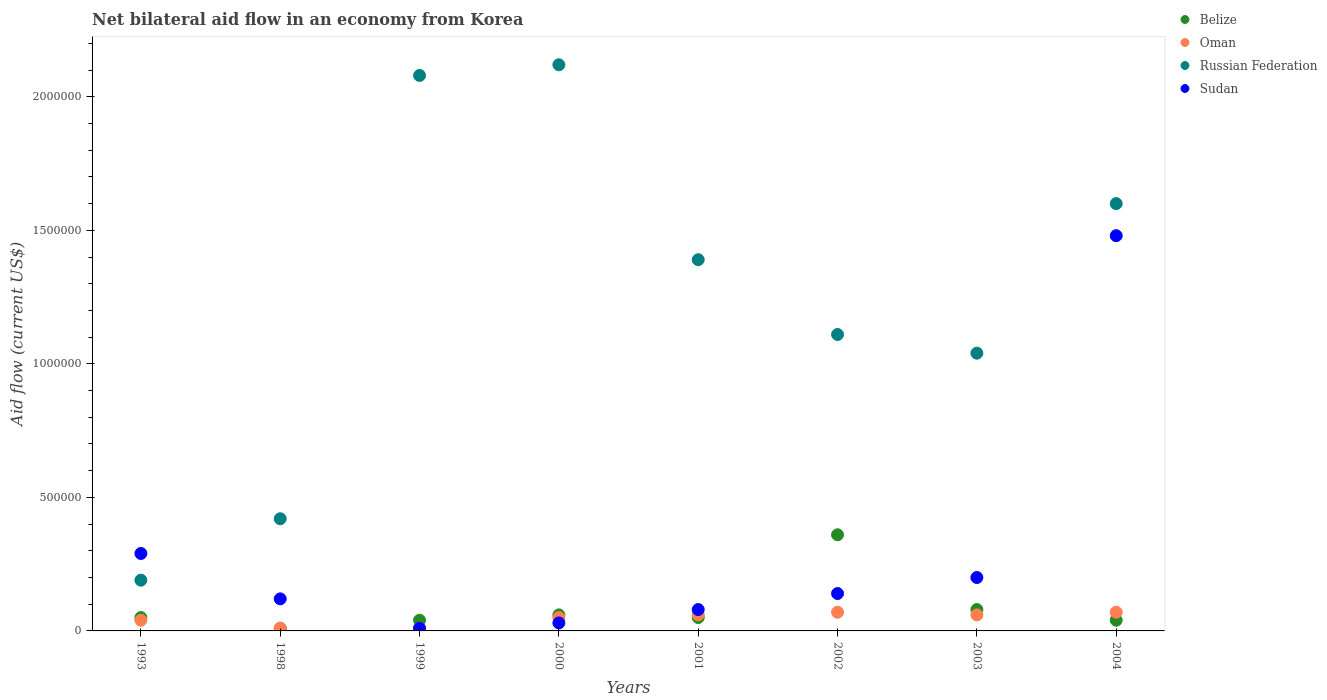How many different coloured dotlines are there?
Make the answer very short. 4. Is the number of dotlines equal to the number of legend labels?
Provide a succinct answer. Yes. Across all years, what is the maximum net bilateral aid flow in Oman?
Your response must be concise. 7.00e+04. Across all years, what is the minimum net bilateral aid flow in Russian Federation?
Your response must be concise. 1.90e+05. In which year was the net bilateral aid flow in Belize maximum?
Provide a succinct answer. 2002. What is the total net bilateral aid flow in Oman in the graph?
Your response must be concise. 3.70e+05. What is the difference between the net bilateral aid flow in Sudan in 2000 and that in 2004?
Give a very brief answer. -1.45e+06. What is the difference between the net bilateral aid flow in Oman in 2003 and the net bilateral aid flow in Russian Federation in 1999?
Give a very brief answer. -2.02e+06. What is the average net bilateral aid flow in Belize per year?
Provide a short and direct response. 8.62e+04. In the year 2003, what is the difference between the net bilateral aid flow in Russian Federation and net bilateral aid flow in Belize?
Provide a short and direct response. 9.60e+05. In how many years, is the net bilateral aid flow in Oman greater than 1800000 US$?
Offer a very short reply. 0. What is the ratio of the net bilateral aid flow in Sudan in 2001 to that in 2003?
Offer a very short reply. 0.4. Is the net bilateral aid flow in Russian Federation in 1993 less than that in 2003?
Offer a very short reply. Yes. What is the difference between the highest and the lowest net bilateral aid flow in Oman?
Offer a terse response. 6.00e+04. Is it the case that in every year, the sum of the net bilateral aid flow in Russian Federation and net bilateral aid flow in Sudan  is greater than the net bilateral aid flow in Belize?
Your response must be concise. Yes. Does the net bilateral aid flow in Belize monotonically increase over the years?
Provide a short and direct response. No. How many years are there in the graph?
Offer a terse response. 8. What is the difference between two consecutive major ticks on the Y-axis?
Make the answer very short. 5.00e+05. Does the graph contain any zero values?
Offer a terse response. No. Where does the legend appear in the graph?
Ensure brevity in your answer.  Top right. What is the title of the graph?
Your answer should be very brief. Net bilateral aid flow in an economy from Korea. Does "Qatar" appear as one of the legend labels in the graph?
Your answer should be very brief. No. What is the Aid flow (current US$) in Oman in 1993?
Give a very brief answer. 4.00e+04. What is the Aid flow (current US$) in Russian Federation in 1993?
Provide a short and direct response. 1.90e+05. What is the Aid flow (current US$) of Sudan in 1993?
Offer a terse response. 2.90e+05. What is the Aid flow (current US$) of Russian Federation in 1999?
Offer a terse response. 2.08e+06. What is the Aid flow (current US$) in Belize in 2000?
Your answer should be very brief. 6.00e+04. What is the Aid flow (current US$) in Russian Federation in 2000?
Offer a terse response. 2.12e+06. What is the Aid flow (current US$) in Sudan in 2000?
Your answer should be very brief. 3.00e+04. What is the Aid flow (current US$) in Russian Federation in 2001?
Your response must be concise. 1.39e+06. What is the Aid flow (current US$) in Belize in 2002?
Offer a terse response. 3.60e+05. What is the Aid flow (current US$) of Oman in 2002?
Make the answer very short. 7.00e+04. What is the Aid flow (current US$) of Russian Federation in 2002?
Provide a short and direct response. 1.11e+06. What is the Aid flow (current US$) in Belize in 2003?
Provide a succinct answer. 8.00e+04. What is the Aid flow (current US$) in Russian Federation in 2003?
Keep it short and to the point. 1.04e+06. What is the Aid flow (current US$) in Belize in 2004?
Provide a short and direct response. 4.00e+04. What is the Aid flow (current US$) of Oman in 2004?
Make the answer very short. 7.00e+04. What is the Aid flow (current US$) of Russian Federation in 2004?
Provide a succinct answer. 1.60e+06. What is the Aid flow (current US$) of Sudan in 2004?
Provide a succinct answer. 1.48e+06. Across all years, what is the maximum Aid flow (current US$) of Belize?
Your answer should be compact. 3.60e+05. Across all years, what is the maximum Aid flow (current US$) of Oman?
Keep it short and to the point. 7.00e+04. Across all years, what is the maximum Aid flow (current US$) in Russian Federation?
Keep it short and to the point. 2.12e+06. Across all years, what is the maximum Aid flow (current US$) in Sudan?
Make the answer very short. 1.48e+06. Across all years, what is the minimum Aid flow (current US$) in Belize?
Make the answer very short. 10000. What is the total Aid flow (current US$) of Belize in the graph?
Offer a terse response. 6.90e+05. What is the total Aid flow (current US$) of Oman in the graph?
Your answer should be compact. 3.70e+05. What is the total Aid flow (current US$) of Russian Federation in the graph?
Keep it short and to the point. 9.95e+06. What is the total Aid flow (current US$) in Sudan in the graph?
Your response must be concise. 2.35e+06. What is the difference between the Aid flow (current US$) in Belize in 1993 and that in 1998?
Offer a very short reply. 4.00e+04. What is the difference between the Aid flow (current US$) in Oman in 1993 and that in 1998?
Your answer should be very brief. 3.00e+04. What is the difference between the Aid flow (current US$) in Oman in 1993 and that in 1999?
Make the answer very short. 3.00e+04. What is the difference between the Aid flow (current US$) in Russian Federation in 1993 and that in 1999?
Offer a very short reply. -1.89e+06. What is the difference between the Aid flow (current US$) in Sudan in 1993 and that in 1999?
Provide a succinct answer. 2.80e+05. What is the difference between the Aid flow (current US$) of Belize in 1993 and that in 2000?
Provide a succinct answer. -10000. What is the difference between the Aid flow (current US$) of Oman in 1993 and that in 2000?
Offer a very short reply. -10000. What is the difference between the Aid flow (current US$) of Russian Federation in 1993 and that in 2000?
Your answer should be very brief. -1.93e+06. What is the difference between the Aid flow (current US$) of Russian Federation in 1993 and that in 2001?
Give a very brief answer. -1.20e+06. What is the difference between the Aid flow (current US$) in Belize in 1993 and that in 2002?
Offer a very short reply. -3.10e+05. What is the difference between the Aid flow (current US$) in Russian Federation in 1993 and that in 2002?
Make the answer very short. -9.20e+05. What is the difference between the Aid flow (current US$) of Sudan in 1993 and that in 2002?
Provide a succinct answer. 1.50e+05. What is the difference between the Aid flow (current US$) of Belize in 1993 and that in 2003?
Offer a very short reply. -3.00e+04. What is the difference between the Aid flow (current US$) of Oman in 1993 and that in 2003?
Provide a succinct answer. -2.00e+04. What is the difference between the Aid flow (current US$) of Russian Federation in 1993 and that in 2003?
Provide a short and direct response. -8.50e+05. What is the difference between the Aid flow (current US$) of Russian Federation in 1993 and that in 2004?
Provide a succinct answer. -1.41e+06. What is the difference between the Aid flow (current US$) of Sudan in 1993 and that in 2004?
Ensure brevity in your answer.  -1.19e+06. What is the difference between the Aid flow (current US$) in Russian Federation in 1998 and that in 1999?
Keep it short and to the point. -1.66e+06. What is the difference between the Aid flow (current US$) in Belize in 1998 and that in 2000?
Give a very brief answer. -5.00e+04. What is the difference between the Aid flow (current US$) of Russian Federation in 1998 and that in 2000?
Your answer should be very brief. -1.70e+06. What is the difference between the Aid flow (current US$) in Belize in 1998 and that in 2001?
Offer a terse response. -4.00e+04. What is the difference between the Aid flow (current US$) of Russian Federation in 1998 and that in 2001?
Ensure brevity in your answer.  -9.70e+05. What is the difference between the Aid flow (current US$) of Belize in 1998 and that in 2002?
Your answer should be very brief. -3.50e+05. What is the difference between the Aid flow (current US$) of Russian Federation in 1998 and that in 2002?
Offer a terse response. -6.90e+05. What is the difference between the Aid flow (current US$) in Sudan in 1998 and that in 2002?
Ensure brevity in your answer.  -2.00e+04. What is the difference between the Aid flow (current US$) of Belize in 1998 and that in 2003?
Ensure brevity in your answer.  -7.00e+04. What is the difference between the Aid flow (current US$) in Russian Federation in 1998 and that in 2003?
Your answer should be very brief. -6.20e+05. What is the difference between the Aid flow (current US$) of Belize in 1998 and that in 2004?
Keep it short and to the point. -3.00e+04. What is the difference between the Aid flow (current US$) in Russian Federation in 1998 and that in 2004?
Ensure brevity in your answer.  -1.18e+06. What is the difference between the Aid flow (current US$) of Sudan in 1998 and that in 2004?
Your answer should be compact. -1.36e+06. What is the difference between the Aid flow (current US$) of Belize in 1999 and that in 2000?
Make the answer very short. -2.00e+04. What is the difference between the Aid flow (current US$) of Russian Federation in 1999 and that in 2000?
Make the answer very short. -4.00e+04. What is the difference between the Aid flow (current US$) of Oman in 1999 and that in 2001?
Ensure brevity in your answer.  -5.00e+04. What is the difference between the Aid flow (current US$) in Russian Federation in 1999 and that in 2001?
Offer a very short reply. 6.90e+05. What is the difference between the Aid flow (current US$) of Sudan in 1999 and that in 2001?
Make the answer very short. -7.00e+04. What is the difference between the Aid flow (current US$) of Belize in 1999 and that in 2002?
Give a very brief answer. -3.20e+05. What is the difference between the Aid flow (current US$) of Oman in 1999 and that in 2002?
Offer a terse response. -6.00e+04. What is the difference between the Aid flow (current US$) in Russian Federation in 1999 and that in 2002?
Offer a very short reply. 9.70e+05. What is the difference between the Aid flow (current US$) in Sudan in 1999 and that in 2002?
Offer a terse response. -1.30e+05. What is the difference between the Aid flow (current US$) in Belize in 1999 and that in 2003?
Your answer should be compact. -4.00e+04. What is the difference between the Aid flow (current US$) in Oman in 1999 and that in 2003?
Offer a terse response. -5.00e+04. What is the difference between the Aid flow (current US$) of Russian Federation in 1999 and that in 2003?
Keep it short and to the point. 1.04e+06. What is the difference between the Aid flow (current US$) of Russian Federation in 1999 and that in 2004?
Offer a very short reply. 4.80e+05. What is the difference between the Aid flow (current US$) in Sudan in 1999 and that in 2004?
Offer a terse response. -1.47e+06. What is the difference between the Aid flow (current US$) in Oman in 2000 and that in 2001?
Your answer should be very brief. -10000. What is the difference between the Aid flow (current US$) of Russian Federation in 2000 and that in 2001?
Your answer should be very brief. 7.30e+05. What is the difference between the Aid flow (current US$) in Oman in 2000 and that in 2002?
Ensure brevity in your answer.  -2.00e+04. What is the difference between the Aid flow (current US$) of Russian Federation in 2000 and that in 2002?
Make the answer very short. 1.01e+06. What is the difference between the Aid flow (current US$) in Oman in 2000 and that in 2003?
Your answer should be very brief. -10000. What is the difference between the Aid flow (current US$) in Russian Federation in 2000 and that in 2003?
Your answer should be very brief. 1.08e+06. What is the difference between the Aid flow (current US$) of Sudan in 2000 and that in 2003?
Your answer should be compact. -1.70e+05. What is the difference between the Aid flow (current US$) of Russian Federation in 2000 and that in 2004?
Your response must be concise. 5.20e+05. What is the difference between the Aid flow (current US$) of Sudan in 2000 and that in 2004?
Offer a terse response. -1.45e+06. What is the difference between the Aid flow (current US$) in Belize in 2001 and that in 2002?
Keep it short and to the point. -3.10e+05. What is the difference between the Aid flow (current US$) in Oman in 2001 and that in 2002?
Your answer should be compact. -10000. What is the difference between the Aid flow (current US$) in Belize in 2001 and that in 2003?
Offer a terse response. -3.00e+04. What is the difference between the Aid flow (current US$) in Oman in 2001 and that in 2003?
Ensure brevity in your answer.  0. What is the difference between the Aid flow (current US$) in Russian Federation in 2001 and that in 2003?
Provide a short and direct response. 3.50e+05. What is the difference between the Aid flow (current US$) in Sudan in 2001 and that in 2003?
Give a very brief answer. -1.20e+05. What is the difference between the Aid flow (current US$) in Belize in 2001 and that in 2004?
Your answer should be very brief. 10000. What is the difference between the Aid flow (current US$) of Oman in 2001 and that in 2004?
Offer a terse response. -10000. What is the difference between the Aid flow (current US$) in Russian Federation in 2001 and that in 2004?
Offer a very short reply. -2.10e+05. What is the difference between the Aid flow (current US$) in Sudan in 2001 and that in 2004?
Make the answer very short. -1.40e+06. What is the difference between the Aid flow (current US$) of Oman in 2002 and that in 2003?
Keep it short and to the point. 10000. What is the difference between the Aid flow (current US$) in Russian Federation in 2002 and that in 2003?
Provide a short and direct response. 7.00e+04. What is the difference between the Aid flow (current US$) of Sudan in 2002 and that in 2003?
Ensure brevity in your answer.  -6.00e+04. What is the difference between the Aid flow (current US$) in Oman in 2002 and that in 2004?
Ensure brevity in your answer.  0. What is the difference between the Aid flow (current US$) of Russian Federation in 2002 and that in 2004?
Offer a very short reply. -4.90e+05. What is the difference between the Aid flow (current US$) in Sudan in 2002 and that in 2004?
Ensure brevity in your answer.  -1.34e+06. What is the difference between the Aid flow (current US$) in Oman in 2003 and that in 2004?
Keep it short and to the point. -10000. What is the difference between the Aid flow (current US$) in Russian Federation in 2003 and that in 2004?
Offer a terse response. -5.60e+05. What is the difference between the Aid flow (current US$) of Sudan in 2003 and that in 2004?
Your response must be concise. -1.28e+06. What is the difference between the Aid flow (current US$) in Belize in 1993 and the Aid flow (current US$) in Russian Federation in 1998?
Provide a succinct answer. -3.70e+05. What is the difference between the Aid flow (current US$) in Oman in 1993 and the Aid flow (current US$) in Russian Federation in 1998?
Provide a short and direct response. -3.80e+05. What is the difference between the Aid flow (current US$) in Oman in 1993 and the Aid flow (current US$) in Sudan in 1998?
Your answer should be compact. -8.00e+04. What is the difference between the Aid flow (current US$) of Russian Federation in 1993 and the Aid flow (current US$) of Sudan in 1998?
Offer a very short reply. 7.00e+04. What is the difference between the Aid flow (current US$) of Belize in 1993 and the Aid flow (current US$) of Russian Federation in 1999?
Make the answer very short. -2.03e+06. What is the difference between the Aid flow (current US$) of Belize in 1993 and the Aid flow (current US$) of Sudan in 1999?
Give a very brief answer. 4.00e+04. What is the difference between the Aid flow (current US$) of Oman in 1993 and the Aid flow (current US$) of Russian Federation in 1999?
Make the answer very short. -2.04e+06. What is the difference between the Aid flow (current US$) of Oman in 1993 and the Aid flow (current US$) of Sudan in 1999?
Provide a short and direct response. 3.00e+04. What is the difference between the Aid flow (current US$) of Russian Federation in 1993 and the Aid flow (current US$) of Sudan in 1999?
Offer a terse response. 1.80e+05. What is the difference between the Aid flow (current US$) of Belize in 1993 and the Aid flow (current US$) of Oman in 2000?
Your response must be concise. 0. What is the difference between the Aid flow (current US$) in Belize in 1993 and the Aid flow (current US$) in Russian Federation in 2000?
Provide a short and direct response. -2.07e+06. What is the difference between the Aid flow (current US$) of Belize in 1993 and the Aid flow (current US$) of Sudan in 2000?
Ensure brevity in your answer.  2.00e+04. What is the difference between the Aid flow (current US$) in Oman in 1993 and the Aid flow (current US$) in Russian Federation in 2000?
Keep it short and to the point. -2.08e+06. What is the difference between the Aid flow (current US$) of Oman in 1993 and the Aid flow (current US$) of Sudan in 2000?
Your answer should be compact. 10000. What is the difference between the Aid flow (current US$) of Russian Federation in 1993 and the Aid flow (current US$) of Sudan in 2000?
Offer a very short reply. 1.60e+05. What is the difference between the Aid flow (current US$) in Belize in 1993 and the Aid flow (current US$) in Oman in 2001?
Give a very brief answer. -10000. What is the difference between the Aid flow (current US$) in Belize in 1993 and the Aid flow (current US$) in Russian Federation in 2001?
Provide a succinct answer. -1.34e+06. What is the difference between the Aid flow (current US$) of Oman in 1993 and the Aid flow (current US$) of Russian Federation in 2001?
Ensure brevity in your answer.  -1.35e+06. What is the difference between the Aid flow (current US$) in Oman in 1993 and the Aid flow (current US$) in Sudan in 2001?
Your answer should be compact. -4.00e+04. What is the difference between the Aid flow (current US$) of Belize in 1993 and the Aid flow (current US$) of Russian Federation in 2002?
Keep it short and to the point. -1.06e+06. What is the difference between the Aid flow (current US$) in Oman in 1993 and the Aid flow (current US$) in Russian Federation in 2002?
Your response must be concise. -1.07e+06. What is the difference between the Aid flow (current US$) of Belize in 1993 and the Aid flow (current US$) of Russian Federation in 2003?
Ensure brevity in your answer.  -9.90e+05. What is the difference between the Aid flow (current US$) of Oman in 1993 and the Aid flow (current US$) of Russian Federation in 2003?
Offer a terse response. -1.00e+06. What is the difference between the Aid flow (current US$) of Oman in 1993 and the Aid flow (current US$) of Sudan in 2003?
Offer a terse response. -1.60e+05. What is the difference between the Aid flow (current US$) in Russian Federation in 1993 and the Aid flow (current US$) in Sudan in 2003?
Ensure brevity in your answer.  -10000. What is the difference between the Aid flow (current US$) in Belize in 1993 and the Aid flow (current US$) in Russian Federation in 2004?
Your answer should be very brief. -1.55e+06. What is the difference between the Aid flow (current US$) of Belize in 1993 and the Aid flow (current US$) of Sudan in 2004?
Your answer should be very brief. -1.43e+06. What is the difference between the Aid flow (current US$) in Oman in 1993 and the Aid flow (current US$) in Russian Federation in 2004?
Provide a short and direct response. -1.56e+06. What is the difference between the Aid flow (current US$) of Oman in 1993 and the Aid flow (current US$) of Sudan in 2004?
Ensure brevity in your answer.  -1.44e+06. What is the difference between the Aid flow (current US$) of Russian Federation in 1993 and the Aid flow (current US$) of Sudan in 2004?
Offer a very short reply. -1.29e+06. What is the difference between the Aid flow (current US$) in Belize in 1998 and the Aid flow (current US$) in Russian Federation in 1999?
Make the answer very short. -2.07e+06. What is the difference between the Aid flow (current US$) in Oman in 1998 and the Aid flow (current US$) in Russian Federation in 1999?
Provide a succinct answer. -2.07e+06. What is the difference between the Aid flow (current US$) of Russian Federation in 1998 and the Aid flow (current US$) of Sudan in 1999?
Provide a short and direct response. 4.10e+05. What is the difference between the Aid flow (current US$) of Belize in 1998 and the Aid flow (current US$) of Oman in 2000?
Offer a terse response. -4.00e+04. What is the difference between the Aid flow (current US$) of Belize in 1998 and the Aid flow (current US$) of Russian Federation in 2000?
Keep it short and to the point. -2.11e+06. What is the difference between the Aid flow (current US$) in Belize in 1998 and the Aid flow (current US$) in Sudan in 2000?
Offer a very short reply. -2.00e+04. What is the difference between the Aid flow (current US$) in Oman in 1998 and the Aid flow (current US$) in Russian Federation in 2000?
Provide a short and direct response. -2.11e+06. What is the difference between the Aid flow (current US$) in Russian Federation in 1998 and the Aid flow (current US$) in Sudan in 2000?
Keep it short and to the point. 3.90e+05. What is the difference between the Aid flow (current US$) in Belize in 1998 and the Aid flow (current US$) in Oman in 2001?
Give a very brief answer. -5.00e+04. What is the difference between the Aid flow (current US$) in Belize in 1998 and the Aid flow (current US$) in Russian Federation in 2001?
Offer a terse response. -1.38e+06. What is the difference between the Aid flow (current US$) of Belize in 1998 and the Aid flow (current US$) of Sudan in 2001?
Provide a short and direct response. -7.00e+04. What is the difference between the Aid flow (current US$) of Oman in 1998 and the Aid flow (current US$) of Russian Federation in 2001?
Your answer should be very brief. -1.38e+06. What is the difference between the Aid flow (current US$) of Oman in 1998 and the Aid flow (current US$) of Sudan in 2001?
Make the answer very short. -7.00e+04. What is the difference between the Aid flow (current US$) in Belize in 1998 and the Aid flow (current US$) in Russian Federation in 2002?
Offer a terse response. -1.10e+06. What is the difference between the Aid flow (current US$) of Belize in 1998 and the Aid flow (current US$) of Sudan in 2002?
Your response must be concise. -1.30e+05. What is the difference between the Aid flow (current US$) of Oman in 1998 and the Aid flow (current US$) of Russian Federation in 2002?
Make the answer very short. -1.10e+06. What is the difference between the Aid flow (current US$) in Belize in 1998 and the Aid flow (current US$) in Russian Federation in 2003?
Provide a succinct answer. -1.03e+06. What is the difference between the Aid flow (current US$) of Belize in 1998 and the Aid flow (current US$) of Sudan in 2003?
Keep it short and to the point. -1.90e+05. What is the difference between the Aid flow (current US$) of Oman in 1998 and the Aid flow (current US$) of Russian Federation in 2003?
Keep it short and to the point. -1.03e+06. What is the difference between the Aid flow (current US$) in Oman in 1998 and the Aid flow (current US$) in Sudan in 2003?
Give a very brief answer. -1.90e+05. What is the difference between the Aid flow (current US$) in Russian Federation in 1998 and the Aid flow (current US$) in Sudan in 2003?
Ensure brevity in your answer.  2.20e+05. What is the difference between the Aid flow (current US$) in Belize in 1998 and the Aid flow (current US$) in Oman in 2004?
Offer a terse response. -6.00e+04. What is the difference between the Aid flow (current US$) in Belize in 1998 and the Aid flow (current US$) in Russian Federation in 2004?
Your answer should be very brief. -1.59e+06. What is the difference between the Aid flow (current US$) of Belize in 1998 and the Aid flow (current US$) of Sudan in 2004?
Provide a succinct answer. -1.47e+06. What is the difference between the Aid flow (current US$) in Oman in 1998 and the Aid flow (current US$) in Russian Federation in 2004?
Make the answer very short. -1.59e+06. What is the difference between the Aid flow (current US$) in Oman in 1998 and the Aid flow (current US$) in Sudan in 2004?
Provide a short and direct response. -1.47e+06. What is the difference between the Aid flow (current US$) of Russian Federation in 1998 and the Aid flow (current US$) of Sudan in 2004?
Provide a short and direct response. -1.06e+06. What is the difference between the Aid flow (current US$) of Belize in 1999 and the Aid flow (current US$) of Oman in 2000?
Provide a succinct answer. -10000. What is the difference between the Aid flow (current US$) in Belize in 1999 and the Aid flow (current US$) in Russian Federation in 2000?
Offer a very short reply. -2.08e+06. What is the difference between the Aid flow (current US$) of Belize in 1999 and the Aid flow (current US$) of Sudan in 2000?
Provide a succinct answer. 10000. What is the difference between the Aid flow (current US$) of Oman in 1999 and the Aid flow (current US$) of Russian Federation in 2000?
Your response must be concise. -2.11e+06. What is the difference between the Aid flow (current US$) of Russian Federation in 1999 and the Aid flow (current US$) of Sudan in 2000?
Ensure brevity in your answer.  2.05e+06. What is the difference between the Aid flow (current US$) of Belize in 1999 and the Aid flow (current US$) of Oman in 2001?
Ensure brevity in your answer.  -2.00e+04. What is the difference between the Aid flow (current US$) of Belize in 1999 and the Aid flow (current US$) of Russian Federation in 2001?
Offer a terse response. -1.35e+06. What is the difference between the Aid flow (current US$) of Oman in 1999 and the Aid flow (current US$) of Russian Federation in 2001?
Offer a terse response. -1.38e+06. What is the difference between the Aid flow (current US$) of Russian Federation in 1999 and the Aid flow (current US$) of Sudan in 2001?
Provide a short and direct response. 2.00e+06. What is the difference between the Aid flow (current US$) in Belize in 1999 and the Aid flow (current US$) in Oman in 2002?
Offer a terse response. -3.00e+04. What is the difference between the Aid flow (current US$) in Belize in 1999 and the Aid flow (current US$) in Russian Federation in 2002?
Offer a very short reply. -1.07e+06. What is the difference between the Aid flow (current US$) in Oman in 1999 and the Aid flow (current US$) in Russian Federation in 2002?
Offer a very short reply. -1.10e+06. What is the difference between the Aid flow (current US$) in Russian Federation in 1999 and the Aid flow (current US$) in Sudan in 2002?
Offer a terse response. 1.94e+06. What is the difference between the Aid flow (current US$) of Belize in 1999 and the Aid flow (current US$) of Oman in 2003?
Provide a short and direct response. -2.00e+04. What is the difference between the Aid flow (current US$) of Belize in 1999 and the Aid flow (current US$) of Russian Federation in 2003?
Your answer should be compact. -1.00e+06. What is the difference between the Aid flow (current US$) in Belize in 1999 and the Aid flow (current US$) in Sudan in 2003?
Make the answer very short. -1.60e+05. What is the difference between the Aid flow (current US$) in Oman in 1999 and the Aid flow (current US$) in Russian Federation in 2003?
Give a very brief answer. -1.03e+06. What is the difference between the Aid flow (current US$) in Russian Federation in 1999 and the Aid flow (current US$) in Sudan in 2003?
Ensure brevity in your answer.  1.88e+06. What is the difference between the Aid flow (current US$) in Belize in 1999 and the Aid flow (current US$) in Russian Federation in 2004?
Ensure brevity in your answer.  -1.56e+06. What is the difference between the Aid flow (current US$) in Belize in 1999 and the Aid flow (current US$) in Sudan in 2004?
Your response must be concise. -1.44e+06. What is the difference between the Aid flow (current US$) in Oman in 1999 and the Aid flow (current US$) in Russian Federation in 2004?
Ensure brevity in your answer.  -1.59e+06. What is the difference between the Aid flow (current US$) in Oman in 1999 and the Aid flow (current US$) in Sudan in 2004?
Make the answer very short. -1.47e+06. What is the difference between the Aid flow (current US$) in Russian Federation in 1999 and the Aid flow (current US$) in Sudan in 2004?
Make the answer very short. 6.00e+05. What is the difference between the Aid flow (current US$) of Belize in 2000 and the Aid flow (current US$) of Oman in 2001?
Offer a very short reply. 0. What is the difference between the Aid flow (current US$) in Belize in 2000 and the Aid flow (current US$) in Russian Federation in 2001?
Your answer should be compact. -1.33e+06. What is the difference between the Aid flow (current US$) in Oman in 2000 and the Aid flow (current US$) in Russian Federation in 2001?
Provide a short and direct response. -1.34e+06. What is the difference between the Aid flow (current US$) in Oman in 2000 and the Aid flow (current US$) in Sudan in 2001?
Provide a short and direct response. -3.00e+04. What is the difference between the Aid flow (current US$) of Russian Federation in 2000 and the Aid flow (current US$) of Sudan in 2001?
Your answer should be compact. 2.04e+06. What is the difference between the Aid flow (current US$) in Belize in 2000 and the Aid flow (current US$) in Russian Federation in 2002?
Your answer should be compact. -1.05e+06. What is the difference between the Aid flow (current US$) in Oman in 2000 and the Aid flow (current US$) in Russian Federation in 2002?
Give a very brief answer. -1.06e+06. What is the difference between the Aid flow (current US$) of Russian Federation in 2000 and the Aid flow (current US$) of Sudan in 2002?
Give a very brief answer. 1.98e+06. What is the difference between the Aid flow (current US$) of Belize in 2000 and the Aid flow (current US$) of Oman in 2003?
Ensure brevity in your answer.  0. What is the difference between the Aid flow (current US$) of Belize in 2000 and the Aid flow (current US$) of Russian Federation in 2003?
Keep it short and to the point. -9.80e+05. What is the difference between the Aid flow (current US$) of Oman in 2000 and the Aid flow (current US$) of Russian Federation in 2003?
Offer a terse response. -9.90e+05. What is the difference between the Aid flow (current US$) of Oman in 2000 and the Aid flow (current US$) of Sudan in 2003?
Keep it short and to the point. -1.50e+05. What is the difference between the Aid flow (current US$) of Russian Federation in 2000 and the Aid flow (current US$) of Sudan in 2003?
Keep it short and to the point. 1.92e+06. What is the difference between the Aid flow (current US$) in Belize in 2000 and the Aid flow (current US$) in Oman in 2004?
Ensure brevity in your answer.  -10000. What is the difference between the Aid flow (current US$) in Belize in 2000 and the Aid flow (current US$) in Russian Federation in 2004?
Provide a short and direct response. -1.54e+06. What is the difference between the Aid flow (current US$) in Belize in 2000 and the Aid flow (current US$) in Sudan in 2004?
Make the answer very short. -1.42e+06. What is the difference between the Aid flow (current US$) of Oman in 2000 and the Aid flow (current US$) of Russian Federation in 2004?
Ensure brevity in your answer.  -1.55e+06. What is the difference between the Aid flow (current US$) of Oman in 2000 and the Aid flow (current US$) of Sudan in 2004?
Give a very brief answer. -1.43e+06. What is the difference between the Aid flow (current US$) in Russian Federation in 2000 and the Aid flow (current US$) in Sudan in 2004?
Ensure brevity in your answer.  6.40e+05. What is the difference between the Aid flow (current US$) of Belize in 2001 and the Aid flow (current US$) of Russian Federation in 2002?
Your answer should be compact. -1.06e+06. What is the difference between the Aid flow (current US$) in Belize in 2001 and the Aid flow (current US$) in Sudan in 2002?
Give a very brief answer. -9.00e+04. What is the difference between the Aid flow (current US$) of Oman in 2001 and the Aid flow (current US$) of Russian Federation in 2002?
Give a very brief answer. -1.05e+06. What is the difference between the Aid flow (current US$) in Oman in 2001 and the Aid flow (current US$) in Sudan in 2002?
Your response must be concise. -8.00e+04. What is the difference between the Aid flow (current US$) in Russian Federation in 2001 and the Aid flow (current US$) in Sudan in 2002?
Keep it short and to the point. 1.25e+06. What is the difference between the Aid flow (current US$) in Belize in 2001 and the Aid flow (current US$) in Oman in 2003?
Keep it short and to the point. -10000. What is the difference between the Aid flow (current US$) in Belize in 2001 and the Aid flow (current US$) in Russian Federation in 2003?
Your response must be concise. -9.90e+05. What is the difference between the Aid flow (current US$) in Oman in 2001 and the Aid flow (current US$) in Russian Federation in 2003?
Your answer should be very brief. -9.80e+05. What is the difference between the Aid flow (current US$) in Russian Federation in 2001 and the Aid flow (current US$) in Sudan in 2003?
Offer a terse response. 1.19e+06. What is the difference between the Aid flow (current US$) of Belize in 2001 and the Aid flow (current US$) of Oman in 2004?
Your response must be concise. -2.00e+04. What is the difference between the Aid flow (current US$) of Belize in 2001 and the Aid flow (current US$) of Russian Federation in 2004?
Your answer should be compact. -1.55e+06. What is the difference between the Aid flow (current US$) of Belize in 2001 and the Aid flow (current US$) of Sudan in 2004?
Ensure brevity in your answer.  -1.43e+06. What is the difference between the Aid flow (current US$) in Oman in 2001 and the Aid flow (current US$) in Russian Federation in 2004?
Provide a succinct answer. -1.54e+06. What is the difference between the Aid flow (current US$) in Oman in 2001 and the Aid flow (current US$) in Sudan in 2004?
Your response must be concise. -1.42e+06. What is the difference between the Aid flow (current US$) of Belize in 2002 and the Aid flow (current US$) of Oman in 2003?
Your answer should be very brief. 3.00e+05. What is the difference between the Aid flow (current US$) of Belize in 2002 and the Aid flow (current US$) of Russian Federation in 2003?
Keep it short and to the point. -6.80e+05. What is the difference between the Aid flow (current US$) of Belize in 2002 and the Aid flow (current US$) of Sudan in 2003?
Give a very brief answer. 1.60e+05. What is the difference between the Aid flow (current US$) in Oman in 2002 and the Aid flow (current US$) in Russian Federation in 2003?
Provide a short and direct response. -9.70e+05. What is the difference between the Aid flow (current US$) in Oman in 2002 and the Aid flow (current US$) in Sudan in 2003?
Offer a very short reply. -1.30e+05. What is the difference between the Aid flow (current US$) in Russian Federation in 2002 and the Aid flow (current US$) in Sudan in 2003?
Provide a short and direct response. 9.10e+05. What is the difference between the Aid flow (current US$) of Belize in 2002 and the Aid flow (current US$) of Russian Federation in 2004?
Your answer should be compact. -1.24e+06. What is the difference between the Aid flow (current US$) in Belize in 2002 and the Aid flow (current US$) in Sudan in 2004?
Provide a succinct answer. -1.12e+06. What is the difference between the Aid flow (current US$) in Oman in 2002 and the Aid flow (current US$) in Russian Federation in 2004?
Offer a terse response. -1.53e+06. What is the difference between the Aid flow (current US$) of Oman in 2002 and the Aid flow (current US$) of Sudan in 2004?
Keep it short and to the point. -1.41e+06. What is the difference between the Aid flow (current US$) in Russian Federation in 2002 and the Aid flow (current US$) in Sudan in 2004?
Make the answer very short. -3.70e+05. What is the difference between the Aid flow (current US$) of Belize in 2003 and the Aid flow (current US$) of Russian Federation in 2004?
Offer a very short reply. -1.52e+06. What is the difference between the Aid flow (current US$) in Belize in 2003 and the Aid flow (current US$) in Sudan in 2004?
Your response must be concise. -1.40e+06. What is the difference between the Aid flow (current US$) of Oman in 2003 and the Aid flow (current US$) of Russian Federation in 2004?
Offer a terse response. -1.54e+06. What is the difference between the Aid flow (current US$) of Oman in 2003 and the Aid flow (current US$) of Sudan in 2004?
Provide a succinct answer. -1.42e+06. What is the difference between the Aid flow (current US$) in Russian Federation in 2003 and the Aid flow (current US$) in Sudan in 2004?
Your response must be concise. -4.40e+05. What is the average Aid flow (current US$) in Belize per year?
Your answer should be compact. 8.62e+04. What is the average Aid flow (current US$) of Oman per year?
Offer a very short reply. 4.62e+04. What is the average Aid flow (current US$) in Russian Federation per year?
Ensure brevity in your answer.  1.24e+06. What is the average Aid flow (current US$) in Sudan per year?
Ensure brevity in your answer.  2.94e+05. In the year 1993, what is the difference between the Aid flow (current US$) in Belize and Aid flow (current US$) in Russian Federation?
Your answer should be compact. -1.40e+05. In the year 1993, what is the difference between the Aid flow (current US$) of Belize and Aid flow (current US$) of Sudan?
Offer a terse response. -2.40e+05. In the year 1993, what is the difference between the Aid flow (current US$) of Oman and Aid flow (current US$) of Russian Federation?
Your response must be concise. -1.50e+05. In the year 1998, what is the difference between the Aid flow (current US$) of Belize and Aid flow (current US$) of Russian Federation?
Your response must be concise. -4.10e+05. In the year 1998, what is the difference between the Aid flow (current US$) in Belize and Aid flow (current US$) in Sudan?
Keep it short and to the point. -1.10e+05. In the year 1998, what is the difference between the Aid flow (current US$) of Oman and Aid flow (current US$) of Russian Federation?
Provide a succinct answer. -4.10e+05. In the year 1998, what is the difference between the Aid flow (current US$) in Oman and Aid flow (current US$) in Sudan?
Give a very brief answer. -1.10e+05. In the year 1998, what is the difference between the Aid flow (current US$) of Russian Federation and Aid flow (current US$) of Sudan?
Keep it short and to the point. 3.00e+05. In the year 1999, what is the difference between the Aid flow (current US$) of Belize and Aid flow (current US$) of Oman?
Your answer should be very brief. 3.00e+04. In the year 1999, what is the difference between the Aid flow (current US$) of Belize and Aid flow (current US$) of Russian Federation?
Your answer should be compact. -2.04e+06. In the year 1999, what is the difference between the Aid flow (current US$) in Belize and Aid flow (current US$) in Sudan?
Offer a terse response. 3.00e+04. In the year 1999, what is the difference between the Aid flow (current US$) of Oman and Aid flow (current US$) of Russian Federation?
Give a very brief answer. -2.07e+06. In the year 1999, what is the difference between the Aid flow (current US$) of Oman and Aid flow (current US$) of Sudan?
Your answer should be very brief. 0. In the year 1999, what is the difference between the Aid flow (current US$) of Russian Federation and Aid flow (current US$) of Sudan?
Keep it short and to the point. 2.07e+06. In the year 2000, what is the difference between the Aid flow (current US$) in Belize and Aid flow (current US$) in Russian Federation?
Keep it short and to the point. -2.06e+06. In the year 2000, what is the difference between the Aid flow (current US$) in Belize and Aid flow (current US$) in Sudan?
Your answer should be very brief. 3.00e+04. In the year 2000, what is the difference between the Aid flow (current US$) in Oman and Aid flow (current US$) in Russian Federation?
Your response must be concise. -2.07e+06. In the year 2000, what is the difference between the Aid flow (current US$) in Russian Federation and Aid flow (current US$) in Sudan?
Your answer should be very brief. 2.09e+06. In the year 2001, what is the difference between the Aid flow (current US$) in Belize and Aid flow (current US$) in Oman?
Your answer should be compact. -10000. In the year 2001, what is the difference between the Aid flow (current US$) in Belize and Aid flow (current US$) in Russian Federation?
Give a very brief answer. -1.34e+06. In the year 2001, what is the difference between the Aid flow (current US$) in Belize and Aid flow (current US$) in Sudan?
Your answer should be compact. -3.00e+04. In the year 2001, what is the difference between the Aid flow (current US$) of Oman and Aid flow (current US$) of Russian Federation?
Offer a very short reply. -1.33e+06. In the year 2001, what is the difference between the Aid flow (current US$) of Oman and Aid flow (current US$) of Sudan?
Keep it short and to the point. -2.00e+04. In the year 2001, what is the difference between the Aid flow (current US$) of Russian Federation and Aid flow (current US$) of Sudan?
Offer a terse response. 1.31e+06. In the year 2002, what is the difference between the Aid flow (current US$) in Belize and Aid flow (current US$) in Russian Federation?
Your answer should be very brief. -7.50e+05. In the year 2002, what is the difference between the Aid flow (current US$) in Oman and Aid flow (current US$) in Russian Federation?
Your answer should be very brief. -1.04e+06. In the year 2002, what is the difference between the Aid flow (current US$) in Oman and Aid flow (current US$) in Sudan?
Your answer should be compact. -7.00e+04. In the year 2002, what is the difference between the Aid flow (current US$) of Russian Federation and Aid flow (current US$) of Sudan?
Provide a succinct answer. 9.70e+05. In the year 2003, what is the difference between the Aid flow (current US$) in Belize and Aid flow (current US$) in Oman?
Your response must be concise. 2.00e+04. In the year 2003, what is the difference between the Aid flow (current US$) in Belize and Aid flow (current US$) in Russian Federation?
Offer a very short reply. -9.60e+05. In the year 2003, what is the difference between the Aid flow (current US$) in Oman and Aid flow (current US$) in Russian Federation?
Provide a succinct answer. -9.80e+05. In the year 2003, what is the difference between the Aid flow (current US$) of Russian Federation and Aid flow (current US$) of Sudan?
Your response must be concise. 8.40e+05. In the year 2004, what is the difference between the Aid flow (current US$) in Belize and Aid flow (current US$) in Oman?
Provide a succinct answer. -3.00e+04. In the year 2004, what is the difference between the Aid flow (current US$) in Belize and Aid flow (current US$) in Russian Federation?
Provide a succinct answer. -1.56e+06. In the year 2004, what is the difference between the Aid flow (current US$) in Belize and Aid flow (current US$) in Sudan?
Ensure brevity in your answer.  -1.44e+06. In the year 2004, what is the difference between the Aid flow (current US$) in Oman and Aid flow (current US$) in Russian Federation?
Your response must be concise. -1.53e+06. In the year 2004, what is the difference between the Aid flow (current US$) in Oman and Aid flow (current US$) in Sudan?
Provide a succinct answer. -1.41e+06. In the year 2004, what is the difference between the Aid flow (current US$) of Russian Federation and Aid flow (current US$) of Sudan?
Your answer should be compact. 1.20e+05. What is the ratio of the Aid flow (current US$) of Oman in 1993 to that in 1998?
Offer a terse response. 4. What is the ratio of the Aid flow (current US$) of Russian Federation in 1993 to that in 1998?
Make the answer very short. 0.45. What is the ratio of the Aid flow (current US$) in Sudan in 1993 to that in 1998?
Provide a succinct answer. 2.42. What is the ratio of the Aid flow (current US$) in Russian Federation in 1993 to that in 1999?
Keep it short and to the point. 0.09. What is the ratio of the Aid flow (current US$) in Belize in 1993 to that in 2000?
Your answer should be compact. 0.83. What is the ratio of the Aid flow (current US$) in Russian Federation in 1993 to that in 2000?
Provide a short and direct response. 0.09. What is the ratio of the Aid flow (current US$) in Sudan in 1993 to that in 2000?
Keep it short and to the point. 9.67. What is the ratio of the Aid flow (current US$) in Belize in 1993 to that in 2001?
Ensure brevity in your answer.  1. What is the ratio of the Aid flow (current US$) of Russian Federation in 1993 to that in 2001?
Give a very brief answer. 0.14. What is the ratio of the Aid flow (current US$) of Sudan in 1993 to that in 2001?
Give a very brief answer. 3.62. What is the ratio of the Aid flow (current US$) of Belize in 1993 to that in 2002?
Provide a succinct answer. 0.14. What is the ratio of the Aid flow (current US$) of Oman in 1993 to that in 2002?
Make the answer very short. 0.57. What is the ratio of the Aid flow (current US$) of Russian Federation in 1993 to that in 2002?
Provide a succinct answer. 0.17. What is the ratio of the Aid flow (current US$) of Sudan in 1993 to that in 2002?
Your response must be concise. 2.07. What is the ratio of the Aid flow (current US$) of Belize in 1993 to that in 2003?
Ensure brevity in your answer.  0.62. What is the ratio of the Aid flow (current US$) of Russian Federation in 1993 to that in 2003?
Your answer should be compact. 0.18. What is the ratio of the Aid flow (current US$) of Sudan in 1993 to that in 2003?
Your response must be concise. 1.45. What is the ratio of the Aid flow (current US$) of Russian Federation in 1993 to that in 2004?
Make the answer very short. 0.12. What is the ratio of the Aid flow (current US$) in Sudan in 1993 to that in 2004?
Make the answer very short. 0.2. What is the ratio of the Aid flow (current US$) of Oman in 1998 to that in 1999?
Your answer should be compact. 1. What is the ratio of the Aid flow (current US$) in Russian Federation in 1998 to that in 1999?
Provide a succinct answer. 0.2. What is the ratio of the Aid flow (current US$) in Sudan in 1998 to that in 1999?
Offer a terse response. 12. What is the ratio of the Aid flow (current US$) of Belize in 1998 to that in 2000?
Provide a short and direct response. 0.17. What is the ratio of the Aid flow (current US$) in Russian Federation in 1998 to that in 2000?
Keep it short and to the point. 0.2. What is the ratio of the Aid flow (current US$) in Sudan in 1998 to that in 2000?
Ensure brevity in your answer.  4. What is the ratio of the Aid flow (current US$) of Belize in 1998 to that in 2001?
Keep it short and to the point. 0.2. What is the ratio of the Aid flow (current US$) of Russian Federation in 1998 to that in 2001?
Your answer should be very brief. 0.3. What is the ratio of the Aid flow (current US$) of Sudan in 1998 to that in 2001?
Provide a short and direct response. 1.5. What is the ratio of the Aid flow (current US$) of Belize in 1998 to that in 2002?
Offer a very short reply. 0.03. What is the ratio of the Aid flow (current US$) in Oman in 1998 to that in 2002?
Keep it short and to the point. 0.14. What is the ratio of the Aid flow (current US$) in Russian Federation in 1998 to that in 2002?
Your answer should be compact. 0.38. What is the ratio of the Aid flow (current US$) of Oman in 1998 to that in 2003?
Your answer should be compact. 0.17. What is the ratio of the Aid flow (current US$) of Russian Federation in 1998 to that in 2003?
Provide a succinct answer. 0.4. What is the ratio of the Aid flow (current US$) of Belize in 1998 to that in 2004?
Provide a short and direct response. 0.25. What is the ratio of the Aid flow (current US$) in Oman in 1998 to that in 2004?
Keep it short and to the point. 0.14. What is the ratio of the Aid flow (current US$) in Russian Federation in 1998 to that in 2004?
Provide a short and direct response. 0.26. What is the ratio of the Aid flow (current US$) in Sudan in 1998 to that in 2004?
Keep it short and to the point. 0.08. What is the ratio of the Aid flow (current US$) of Russian Federation in 1999 to that in 2000?
Offer a very short reply. 0.98. What is the ratio of the Aid flow (current US$) in Sudan in 1999 to that in 2000?
Make the answer very short. 0.33. What is the ratio of the Aid flow (current US$) of Russian Federation in 1999 to that in 2001?
Give a very brief answer. 1.5. What is the ratio of the Aid flow (current US$) in Sudan in 1999 to that in 2001?
Offer a very short reply. 0.12. What is the ratio of the Aid flow (current US$) of Belize in 1999 to that in 2002?
Your answer should be compact. 0.11. What is the ratio of the Aid flow (current US$) of Oman in 1999 to that in 2002?
Offer a very short reply. 0.14. What is the ratio of the Aid flow (current US$) in Russian Federation in 1999 to that in 2002?
Your response must be concise. 1.87. What is the ratio of the Aid flow (current US$) in Sudan in 1999 to that in 2002?
Provide a short and direct response. 0.07. What is the ratio of the Aid flow (current US$) of Belize in 1999 to that in 2003?
Your answer should be compact. 0.5. What is the ratio of the Aid flow (current US$) of Oman in 1999 to that in 2003?
Make the answer very short. 0.17. What is the ratio of the Aid flow (current US$) of Sudan in 1999 to that in 2003?
Make the answer very short. 0.05. What is the ratio of the Aid flow (current US$) of Belize in 1999 to that in 2004?
Your answer should be compact. 1. What is the ratio of the Aid flow (current US$) of Oman in 1999 to that in 2004?
Ensure brevity in your answer.  0.14. What is the ratio of the Aid flow (current US$) in Sudan in 1999 to that in 2004?
Your answer should be compact. 0.01. What is the ratio of the Aid flow (current US$) in Belize in 2000 to that in 2001?
Your answer should be compact. 1.2. What is the ratio of the Aid flow (current US$) of Oman in 2000 to that in 2001?
Provide a succinct answer. 0.83. What is the ratio of the Aid flow (current US$) of Russian Federation in 2000 to that in 2001?
Ensure brevity in your answer.  1.53. What is the ratio of the Aid flow (current US$) of Oman in 2000 to that in 2002?
Your response must be concise. 0.71. What is the ratio of the Aid flow (current US$) of Russian Federation in 2000 to that in 2002?
Make the answer very short. 1.91. What is the ratio of the Aid flow (current US$) of Sudan in 2000 to that in 2002?
Give a very brief answer. 0.21. What is the ratio of the Aid flow (current US$) of Oman in 2000 to that in 2003?
Your answer should be compact. 0.83. What is the ratio of the Aid flow (current US$) of Russian Federation in 2000 to that in 2003?
Keep it short and to the point. 2.04. What is the ratio of the Aid flow (current US$) in Sudan in 2000 to that in 2003?
Ensure brevity in your answer.  0.15. What is the ratio of the Aid flow (current US$) in Belize in 2000 to that in 2004?
Offer a terse response. 1.5. What is the ratio of the Aid flow (current US$) in Oman in 2000 to that in 2004?
Provide a succinct answer. 0.71. What is the ratio of the Aid flow (current US$) in Russian Federation in 2000 to that in 2004?
Provide a short and direct response. 1.32. What is the ratio of the Aid flow (current US$) in Sudan in 2000 to that in 2004?
Offer a very short reply. 0.02. What is the ratio of the Aid flow (current US$) of Belize in 2001 to that in 2002?
Ensure brevity in your answer.  0.14. What is the ratio of the Aid flow (current US$) in Oman in 2001 to that in 2002?
Ensure brevity in your answer.  0.86. What is the ratio of the Aid flow (current US$) in Russian Federation in 2001 to that in 2002?
Provide a short and direct response. 1.25. What is the ratio of the Aid flow (current US$) in Belize in 2001 to that in 2003?
Offer a terse response. 0.62. What is the ratio of the Aid flow (current US$) in Russian Federation in 2001 to that in 2003?
Offer a very short reply. 1.34. What is the ratio of the Aid flow (current US$) in Sudan in 2001 to that in 2003?
Ensure brevity in your answer.  0.4. What is the ratio of the Aid flow (current US$) in Russian Federation in 2001 to that in 2004?
Offer a very short reply. 0.87. What is the ratio of the Aid flow (current US$) of Sudan in 2001 to that in 2004?
Keep it short and to the point. 0.05. What is the ratio of the Aid flow (current US$) in Belize in 2002 to that in 2003?
Provide a short and direct response. 4.5. What is the ratio of the Aid flow (current US$) in Russian Federation in 2002 to that in 2003?
Ensure brevity in your answer.  1.07. What is the ratio of the Aid flow (current US$) in Belize in 2002 to that in 2004?
Your answer should be compact. 9. What is the ratio of the Aid flow (current US$) in Oman in 2002 to that in 2004?
Your answer should be compact. 1. What is the ratio of the Aid flow (current US$) of Russian Federation in 2002 to that in 2004?
Offer a terse response. 0.69. What is the ratio of the Aid flow (current US$) of Sudan in 2002 to that in 2004?
Offer a very short reply. 0.09. What is the ratio of the Aid flow (current US$) of Belize in 2003 to that in 2004?
Your answer should be compact. 2. What is the ratio of the Aid flow (current US$) in Oman in 2003 to that in 2004?
Offer a very short reply. 0.86. What is the ratio of the Aid flow (current US$) of Russian Federation in 2003 to that in 2004?
Make the answer very short. 0.65. What is the ratio of the Aid flow (current US$) of Sudan in 2003 to that in 2004?
Make the answer very short. 0.14. What is the difference between the highest and the second highest Aid flow (current US$) of Belize?
Your response must be concise. 2.80e+05. What is the difference between the highest and the second highest Aid flow (current US$) of Oman?
Your response must be concise. 0. What is the difference between the highest and the second highest Aid flow (current US$) in Sudan?
Keep it short and to the point. 1.19e+06. What is the difference between the highest and the lowest Aid flow (current US$) of Belize?
Give a very brief answer. 3.50e+05. What is the difference between the highest and the lowest Aid flow (current US$) in Russian Federation?
Give a very brief answer. 1.93e+06. What is the difference between the highest and the lowest Aid flow (current US$) in Sudan?
Provide a succinct answer. 1.47e+06. 